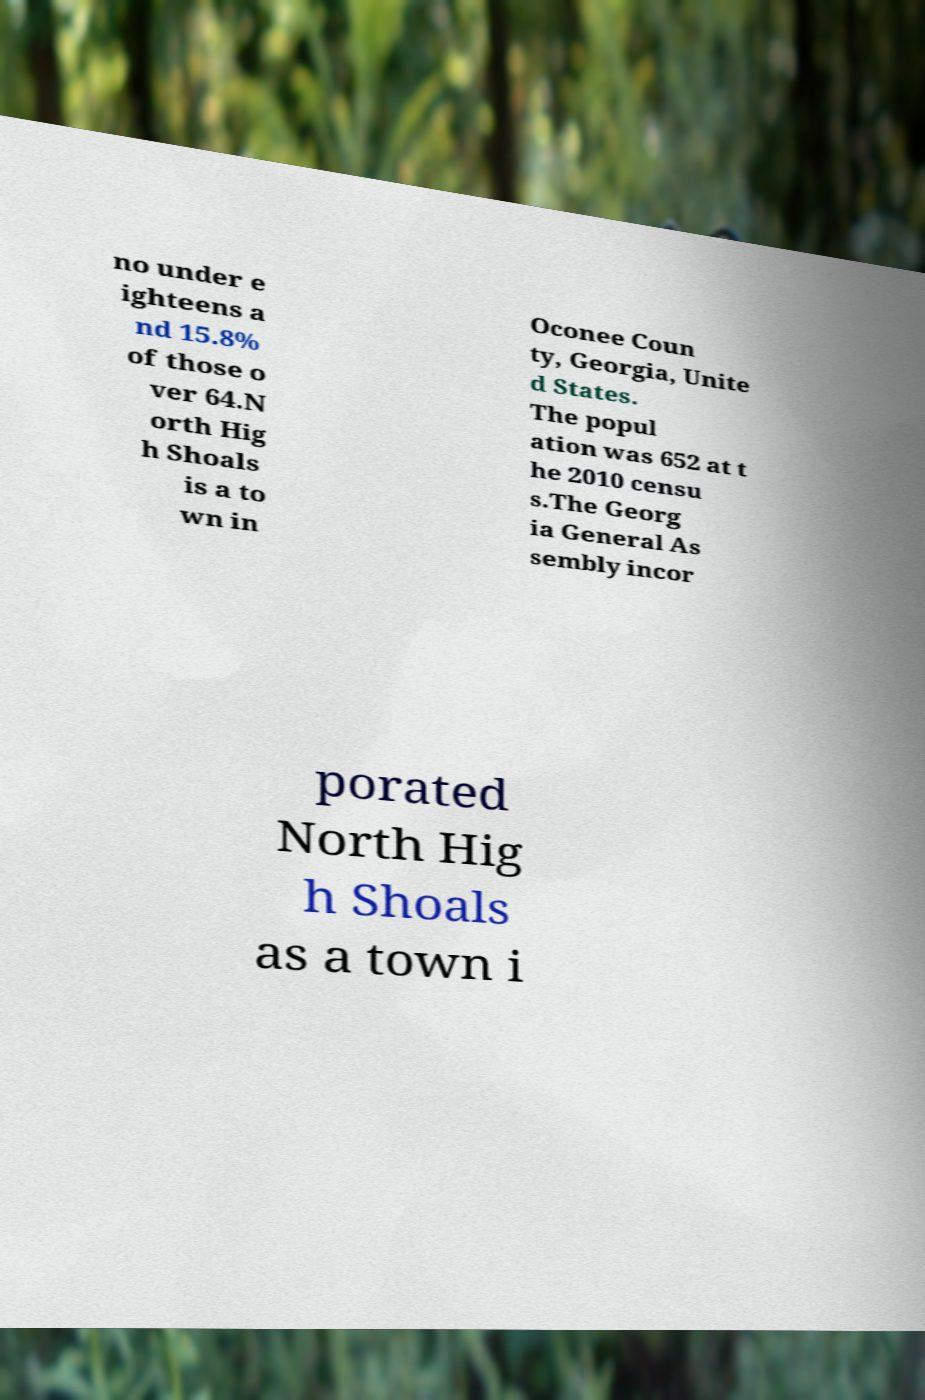Please read and relay the text visible in this image. What does it say? no under e ighteens a nd 15.8% of those o ver 64.N orth Hig h Shoals is a to wn in Oconee Coun ty, Georgia, Unite d States. The popul ation was 652 at t he 2010 censu s.The Georg ia General As sembly incor porated North Hig h Shoals as a town i 